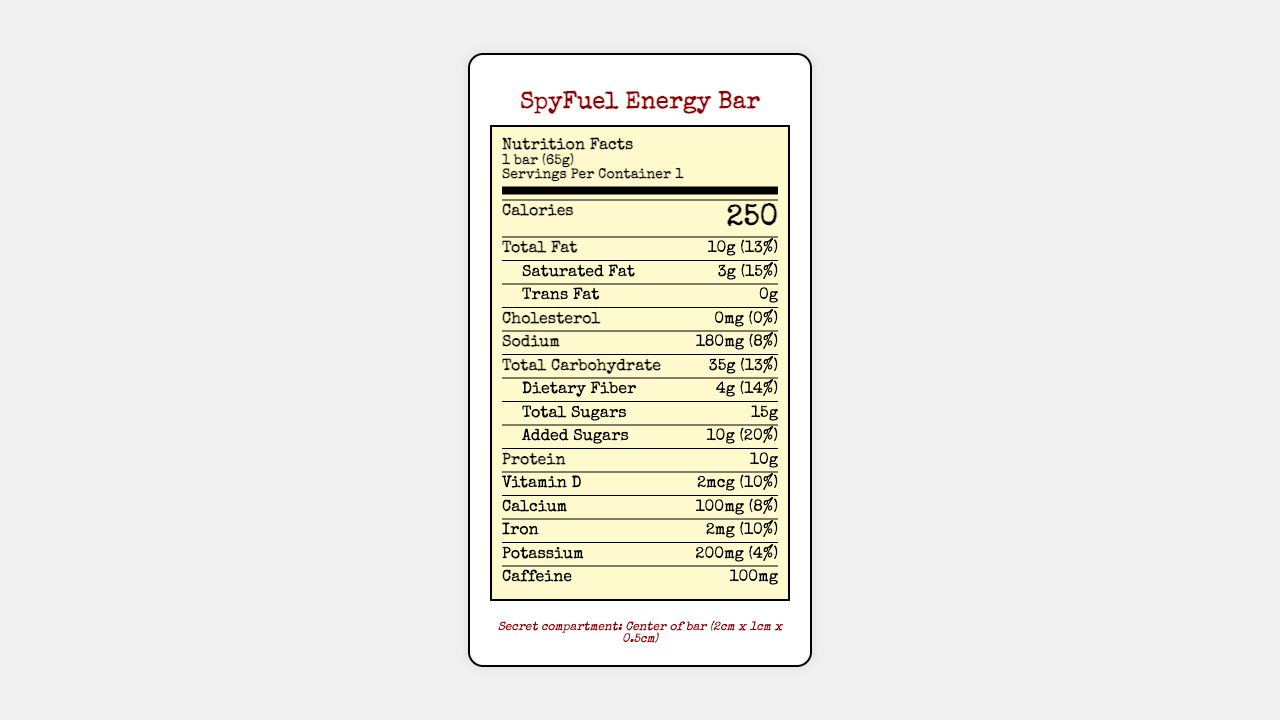what is the serving size for the SpyFuel Energy Bar? The serving size is explicitly mentioned as "1 bar (65g)" on the label.
Answer: 1 bar (65g) how many calories are in one bar? The label states that each serving, which is one bar, contains 250 calories.
Answer: 250 calories what is the amount of protein per serving? The protein content per serving is listed as 10g on the nutrition label.
Answer: 10g how much sodium is in the SpyFuel Energy Bar? The nutrition label indicates that there are 180mg of sodium per serving.
Answer: 180mg is there any cholesterol in the SpyFuel Energy Bar? The label clearly shows that the amount of cholesterol is 0mg, implying there is no cholesterol in the bar.
Answer: No how much Total Fat does this bar contain? The nutrition label mentions that the total fat content is 10g per serving.
Answer: 10g what is the daily value percentage for dietary fiber? The daily value percentage for dietary fiber is 14%, as stated on the label.
Answer: 14% what is the special feature of the SpyFuel Energy Bar? The label mentions a secret compartment located in the center of the bar with dimensions and its purpose for microfilm storage.
Answer: It has a hidden compartment for microfilm storage. what percent of daily value does the added sugars represent? According to the label, the added sugars constitute 20% of the daily value.
Answer: 20% how much caffeine is in the bar? The nutrition label specifies that each bar contains 100mg of caffeine.
Answer: 100mg which ingredient is not listed in the special ingredients? A. Guarana extract B. Ginseng root powder C. Aloe vera D. Taurine The special ingredients listed are Guarana extract, Ginseng root powder, and Taurine; Aloe vera is not listed.
Answer: C what is the shelf life of the SpyFuel Energy Bar? A. 6 months B. 12 months C. 18 months D. 24 months The label specifies that the SpyFuel Energy Bar has a shelf life of 18 months.
Answer: C does the SpyFuel Energy Bar contain tree nuts? The allergen information on the label states that the bar contains soy and tree nuts.
Answer: Yes summarize the main idea of the document. This label provides all necessary nutritional information for the SpyFuel Energy Bar, including calories, fats, vitamins, along with a special compartment for storing microfilm.
Answer: The document is a detailed nutrition facts label for a high-energy SpyFuel Energy Bar, highlighting its nutritional content, special ingredients, hidden compartment for microfilm storage, and other relevant information such as allergen warnings and shelf life. are there any preservatives mentioned in the ingredient list? The document provided does not include a detailed ingredient list apart from the listed special ingredients.
Answer: Not enough information what is the significance of the hidden compartment in the SpyFuel Energy Bar? The spy trivia at the end of the document mentions that the hidden compartment concept is inspired by real-life CIA operations from the Cold War era.
Answer: It is inspired by the CIA's escape and evasion kit used during the Cold War. 